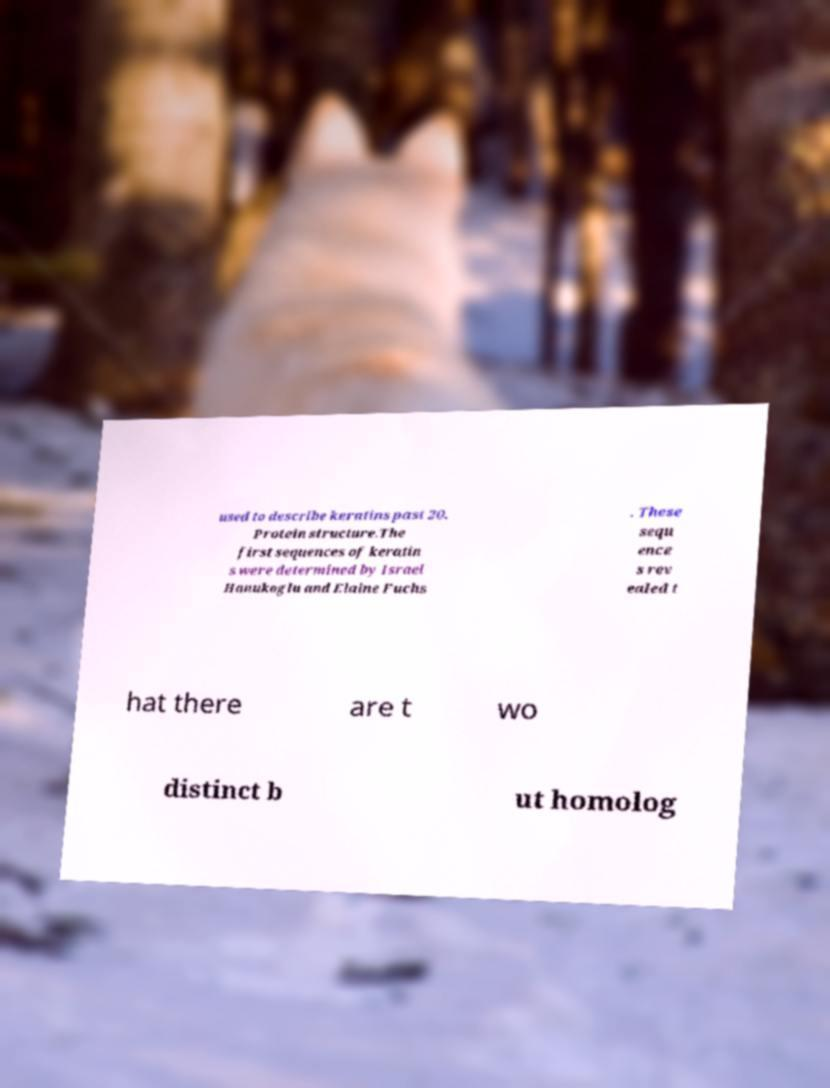Could you assist in decoding the text presented in this image and type it out clearly? used to describe keratins past 20. Protein structure.The first sequences of keratin s were determined by Israel Hanukoglu and Elaine Fuchs . These sequ ence s rev ealed t hat there are t wo distinct b ut homolog 